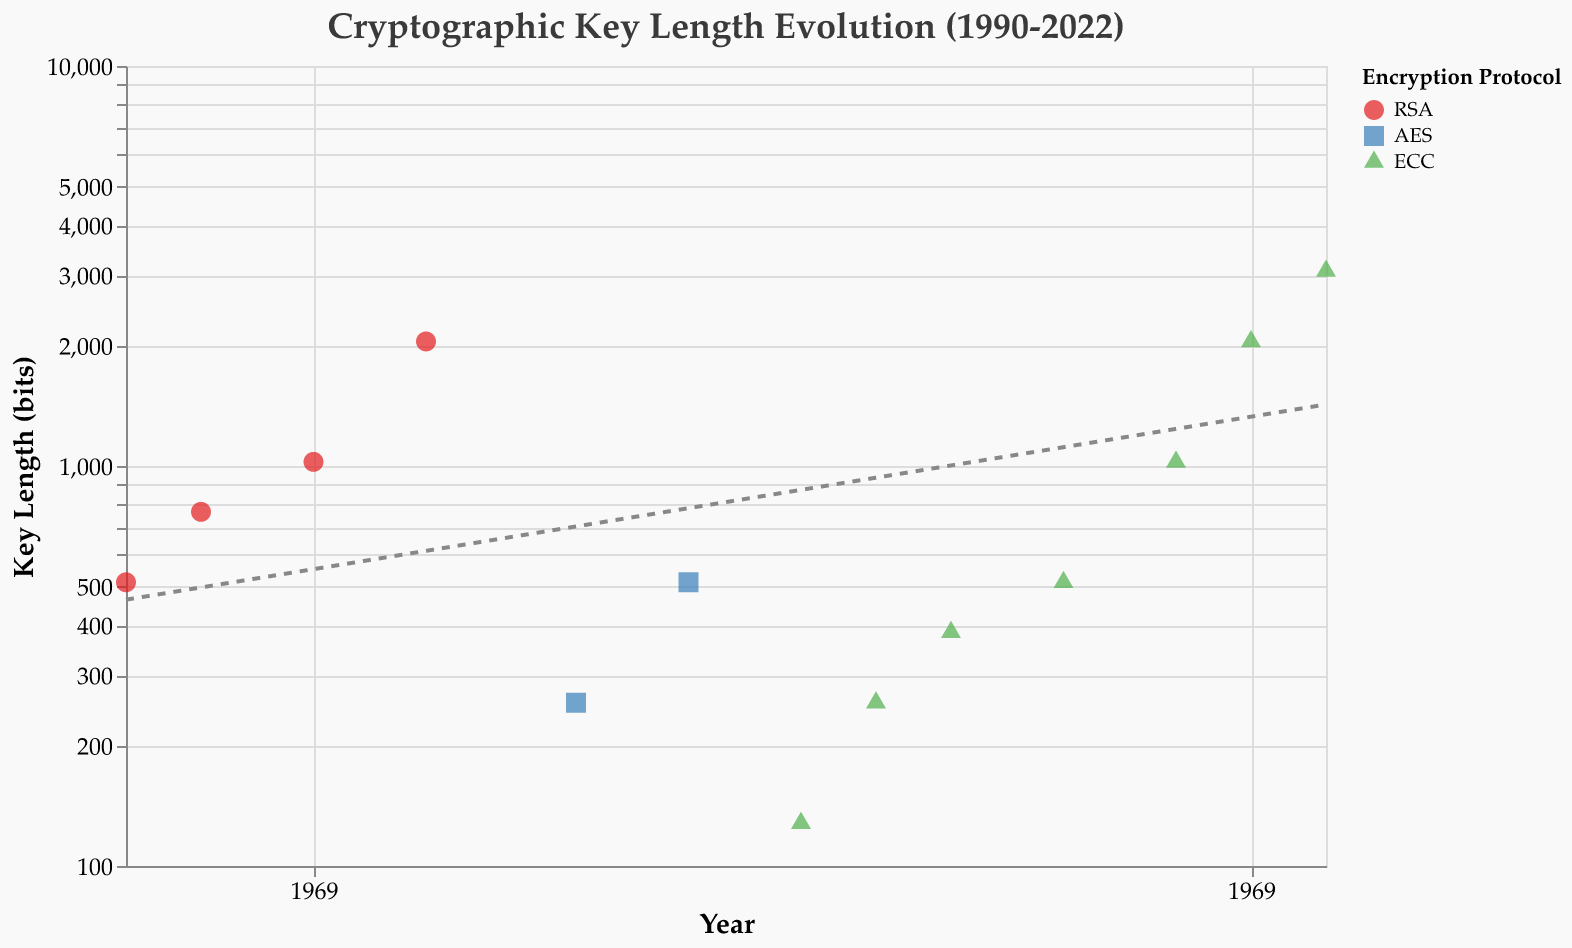What is the title of the figure? The title of the figure is prominently displayed at the top and reads "Cryptographic Key Length Evolution (1990-2022)"
Answer: Cryptographic Key Length Evolution (1990-2022) How many data points are there in the figure? You can determine the number of data points by counting the number of points displayed on the plot. Each point represents a key length for a given year.
Answer: 13 Which encryption protocol had the highest initial key length in the year it first appeared? Compare the key lengths of RSA, AES, and ECC in the years they first appear (1990 for RSA, 2002 for AES, 2008 for ECC). 512 bits for RSA (1990), 256 bits for AES (2002), and 128 bits for ECC (2008). The largest initial key length is 512 bits for RSA.
Answer: RSA By how many bits did the key length for ECC increase from 2008 to 2022? In 2008, ECC had a key length of 128 bits. By 2022, it increased to 3072 bits. The difference is calculated as 3072 - 128.
Answer: 2944 Between which years did ECC see the largest increase in key length? Examine the increments between consecutive data points for ECC and find the pair with the largest jump. The difference between 2020 and 2022 is the largest (2048 bits to 3072 bits).
Answer: 2020 to 2022 What is the security level of RSA in 1998? The security level for RSA in 1998 is shown next to the data point for that year, labeled as "High".
Answer: High Which protocol had the shortest key length in the displayed years? Compare the key lengths of the points for RSA, AES, and ECC and determine the shortest key length. The shortest is 128 bits for ECC in 2008.
Answer: ECC How does the trend line describe the evolution of key lengths over time? The trend line, represented by a dashed line, indicates an overall increase in key lengths over time, suggesting a trend towards stronger security practices.
Answer: Increasing over time Across all encryption protocols, which year had the greatest diversity in key lengths, and what were those lengths? Compare the key lengths across the protocols for each year and identify the year with the most varied key lengths. In 2005, there’s both 128 bits and 2048 bits represented, showing the greatest diversity.
Answer: 2005 (128 bits and 2048 bits) Between which years did the key length for RSA witness the most significant increase? Look for the largest increment within RSA’s data points from 1990, 1992, 1995, to 1998. The most significant increase is from 1995 (1024 bits) to 1998 (2048 bits).
Answer: 1995 to 1998 